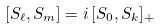Convert formula to latex. <formula><loc_0><loc_0><loc_500><loc_500>[ S _ { \ell } , S _ { m } ] = i \, [ S _ { 0 } , S _ { k } ] _ { + }</formula> 